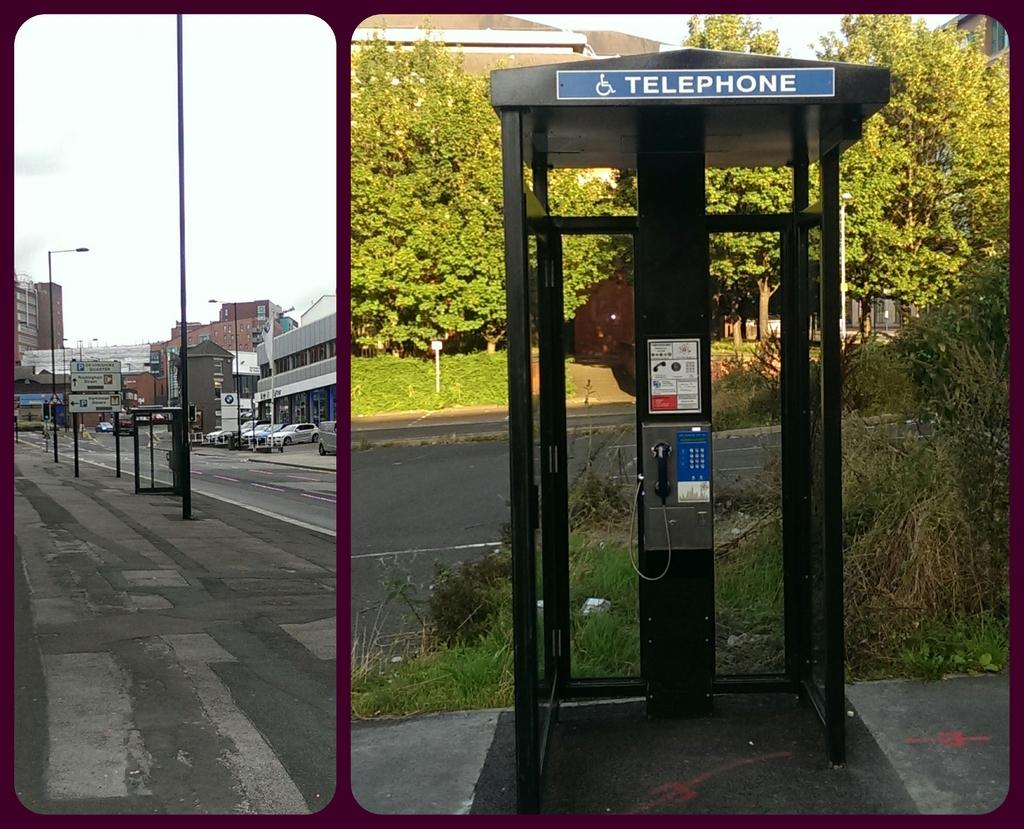<image>
Create a compact narrative representing the image presented. A telephone booth on a sidewalk and a BMW dealership on a city road. 